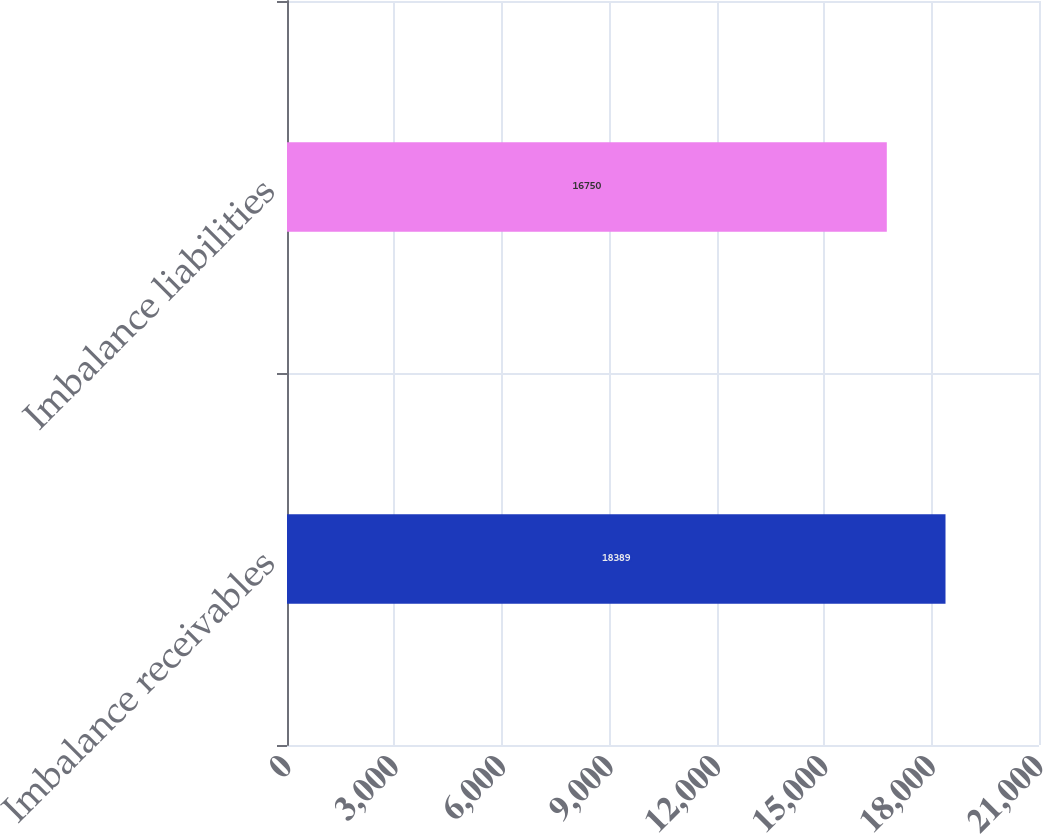Convert chart to OTSL. <chart><loc_0><loc_0><loc_500><loc_500><bar_chart><fcel>Imbalance receivables<fcel>Imbalance liabilities<nl><fcel>18389<fcel>16750<nl></chart> 